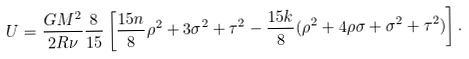<formula> <loc_0><loc_0><loc_500><loc_500>U = \frac { G M ^ { 2 } } { 2 R \nu } \frac { 8 } { 1 5 } \left [ \frac { 1 5 n } { 8 } \rho ^ { 2 } + 3 \sigma ^ { 2 } + \tau ^ { 2 } - \frac { 1 5 k } { 8 } ( \rho ^ { 2 } + 4 \rho \sigma + \sigma ^ { 2 } + \tau ^ { 2 } ) \right ] .</formula> 